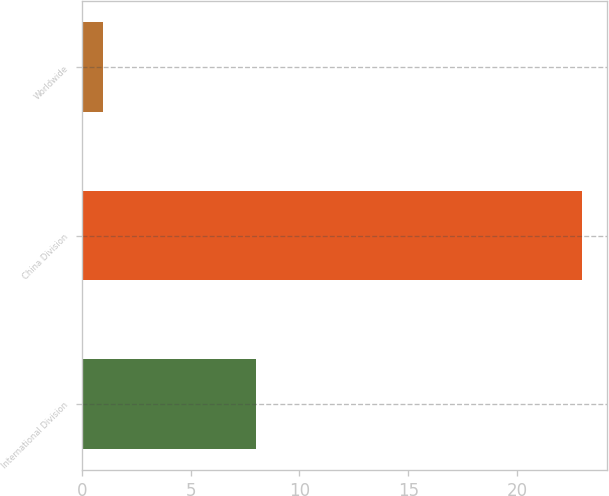<chart> <loc_0><loc_0><loc_500><loc_500><bar_chart><fcel>International Division<fcel>China Division<fcel>Worldwide<nl><fcel>8<fcel>23<fcel>1<nl></chart> 